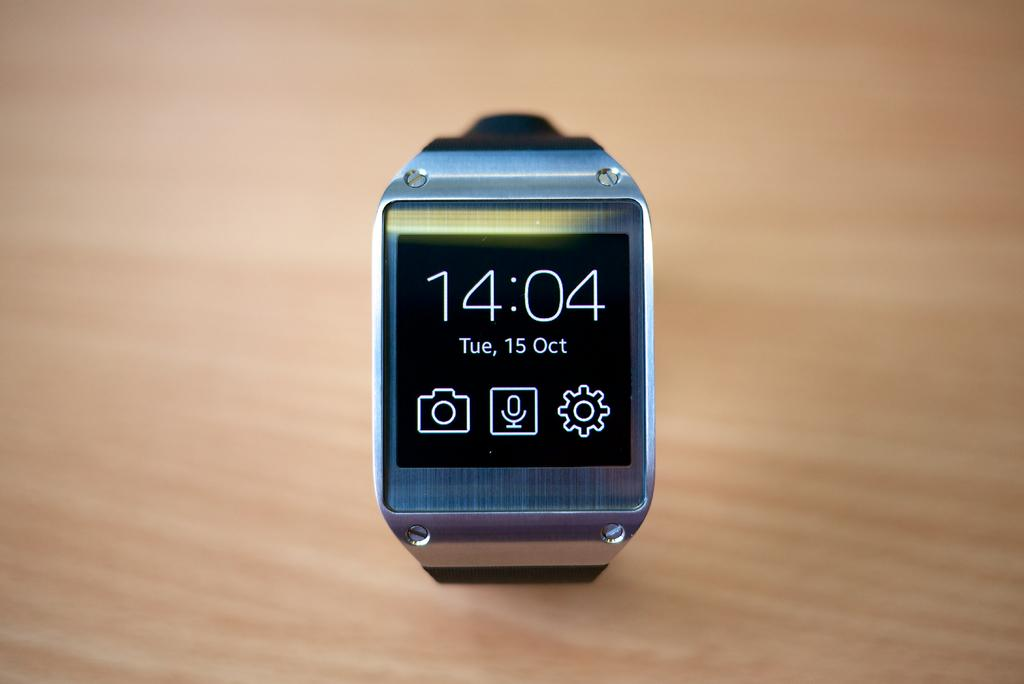<image>
Summarize the visual content of the image. A watch displaying the military time of 14:04 